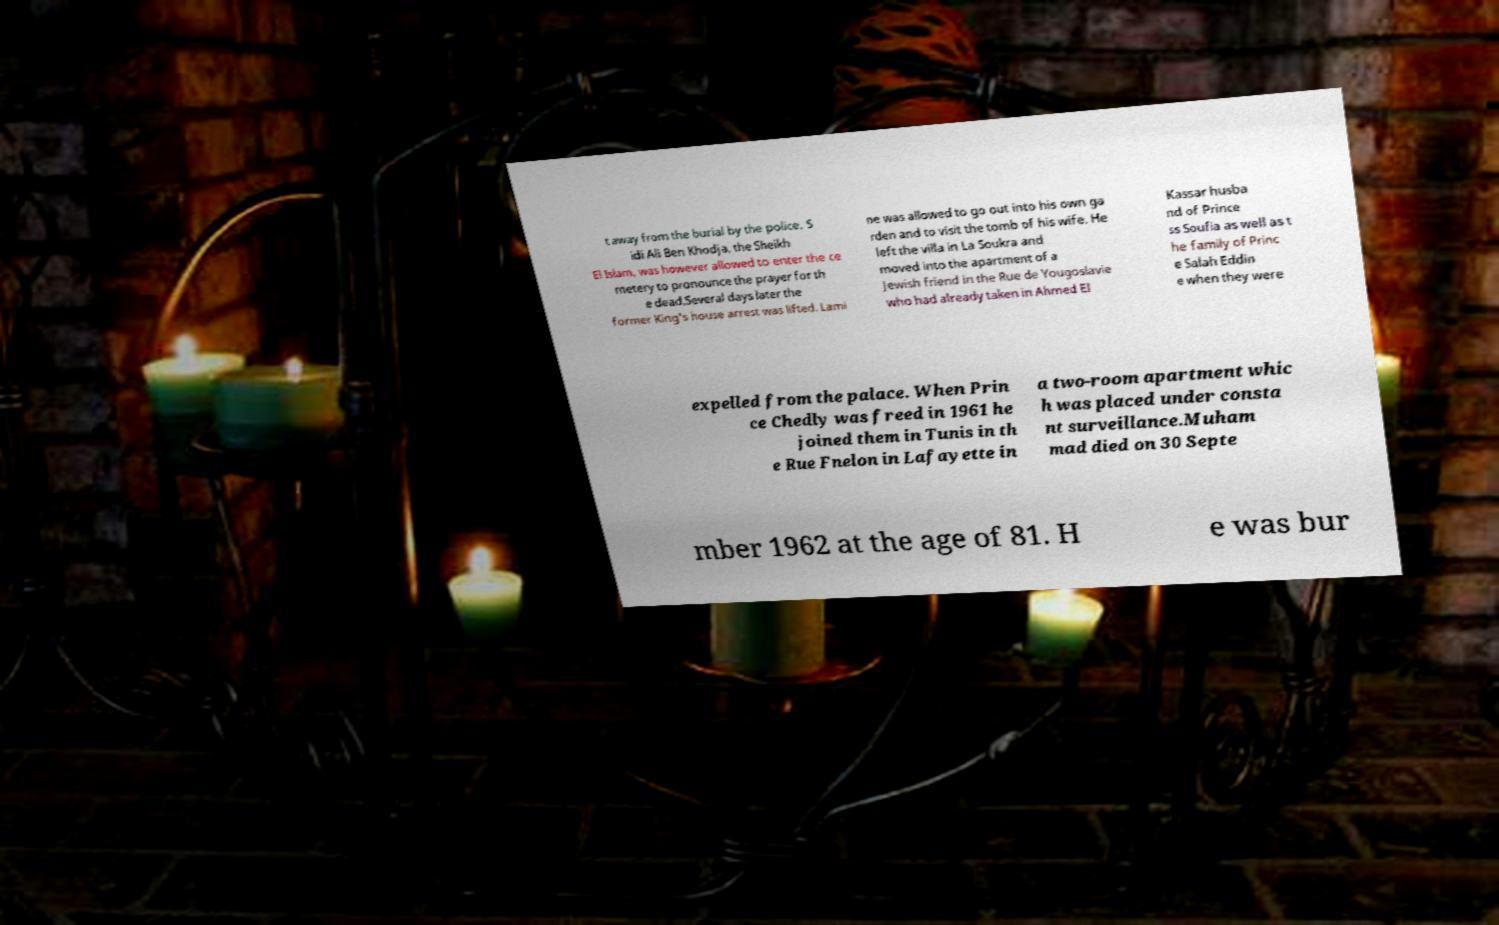Can you read and provide the text displayed in the image?This photo seems to have some interesting text. Can you extract and type it out for me? t away from the burial by the police. S idi Ali Ben Khodja, the Sheikh El Islam, was however allowed to enter the ce metery to pronounce the prayer for th e dead.Several days later the former King's house arrest was lifted. Lami ne was allowed to go out into his own ga rden and to visit the tomb of his wife. He left the villa in La Soukra and moved into the apartment of a Jewish friend in the Rue de Yougoslavie who had already taken in Ahmed El Kassar husba nd of Prince ss Soufia as well as t he family of Princ e Salah Eddin e when they were expelled from the palace. When Prin ce Chedly was freed in 1961 he joined them in Tunis in th e Rue Fnelon in Lafayette in a two-room apartment whic h was placed under consta nt surveillance.Muham mad died on 30 Septe mber 1962 at the age of 81. H e was bur 